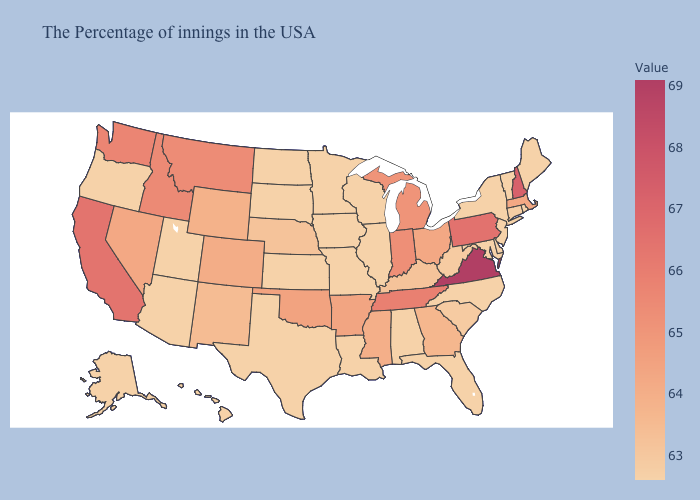Does the map have missing data?
Short answer required. No. Which states hav the highest value in the South?
Write a very short answer. Virginia. Which states have the highest value in the USA?
Concise answer only. Virginia. Which states hav the highest value in the Northeast?
Quick response, please. New Hampshire. 